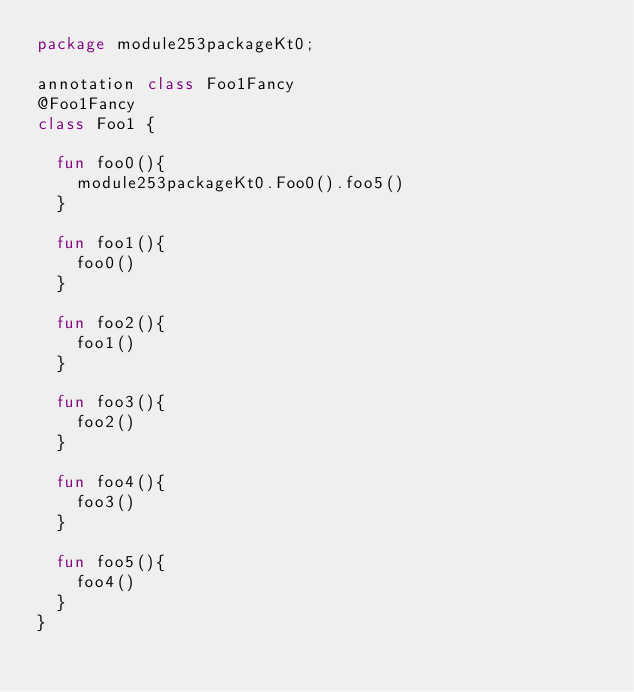<code> <loc_0><loc_0><loc_500><loc_500><_Kotlin_>package module253packageKt0;

annotation class Foo1Fancy
@Foo1Fancy
class Foo1 {

  fun foo0(){
    module253packageKt0.Foo0().foo5()
  }

  fun foo1(){
    foo0()
  }

  fun foo2(){
    foo1()
  }

  fun foo3(){
    foo2()
  }

  fun foo4(){
    foo3()
  }

  fun foo5(){
    foo4()
  }
}</code> 